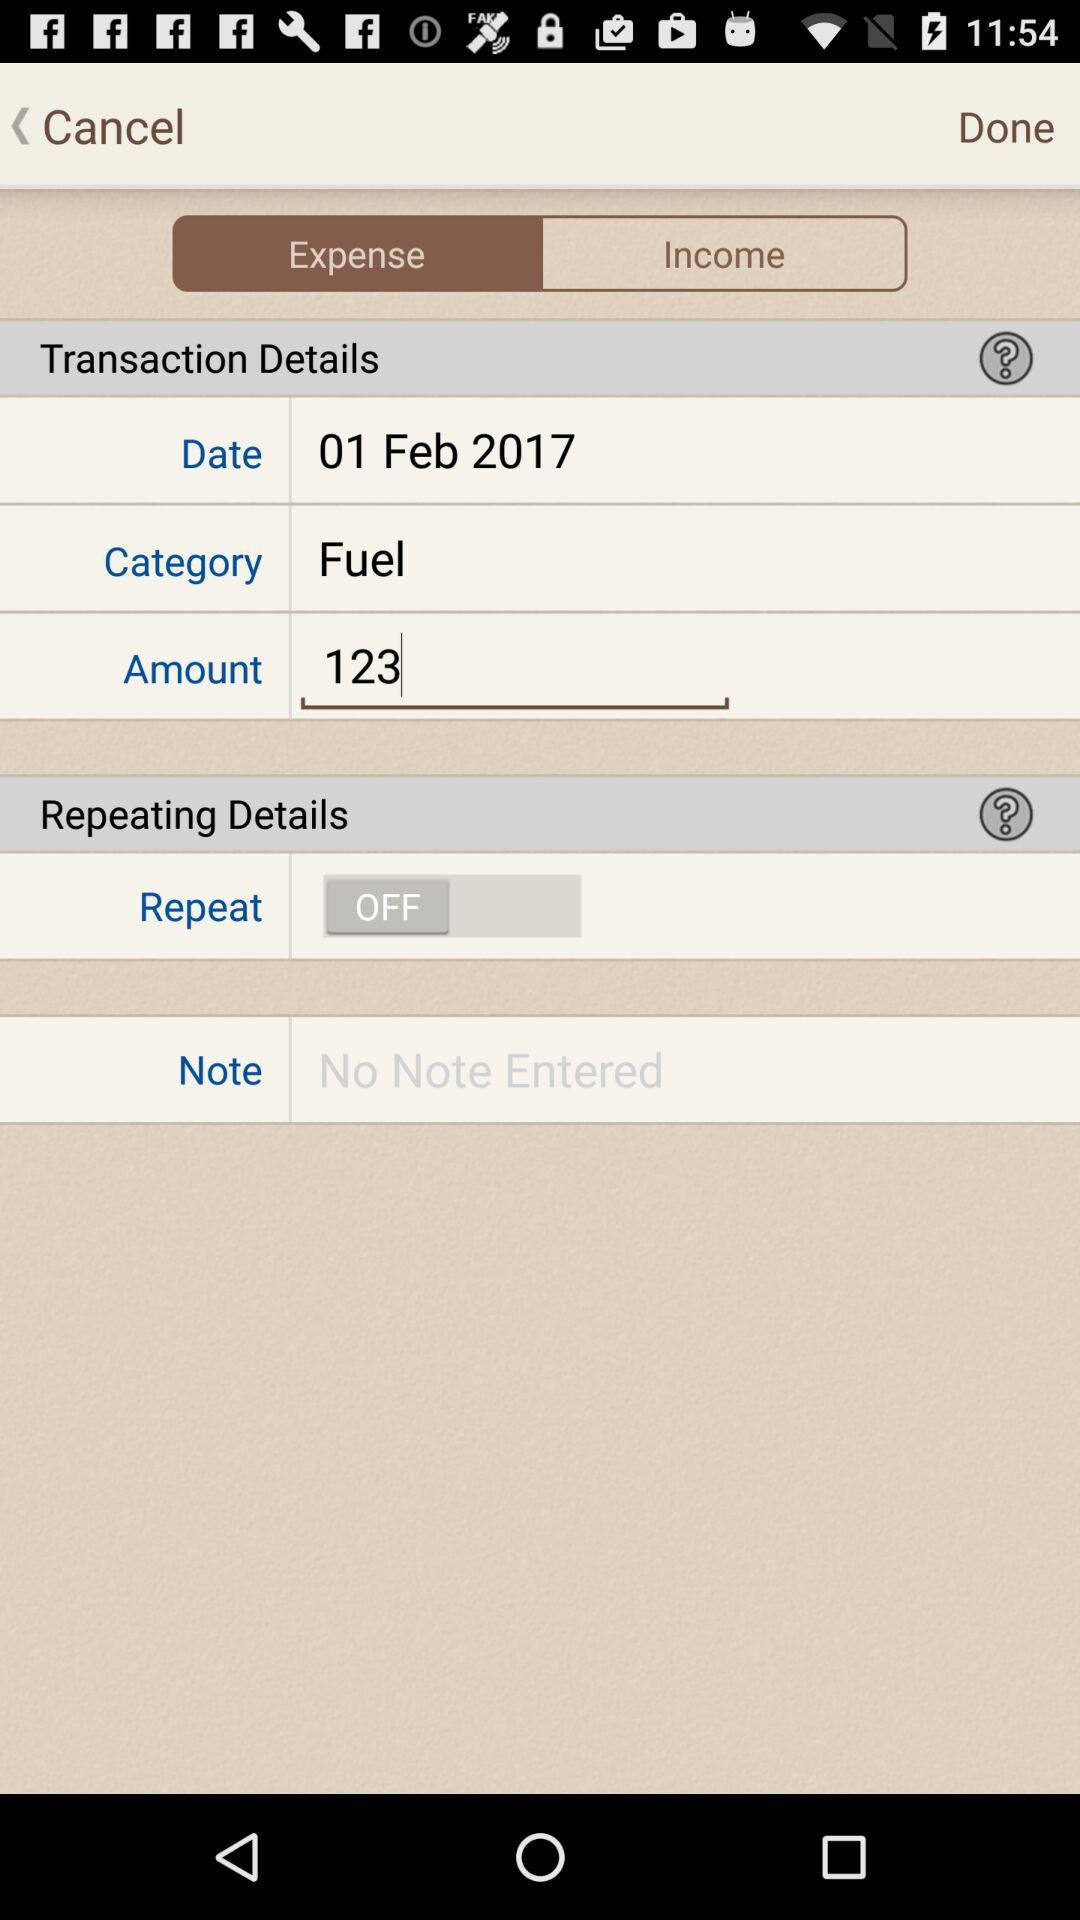What is the entered amount? The entered amount is 123. 